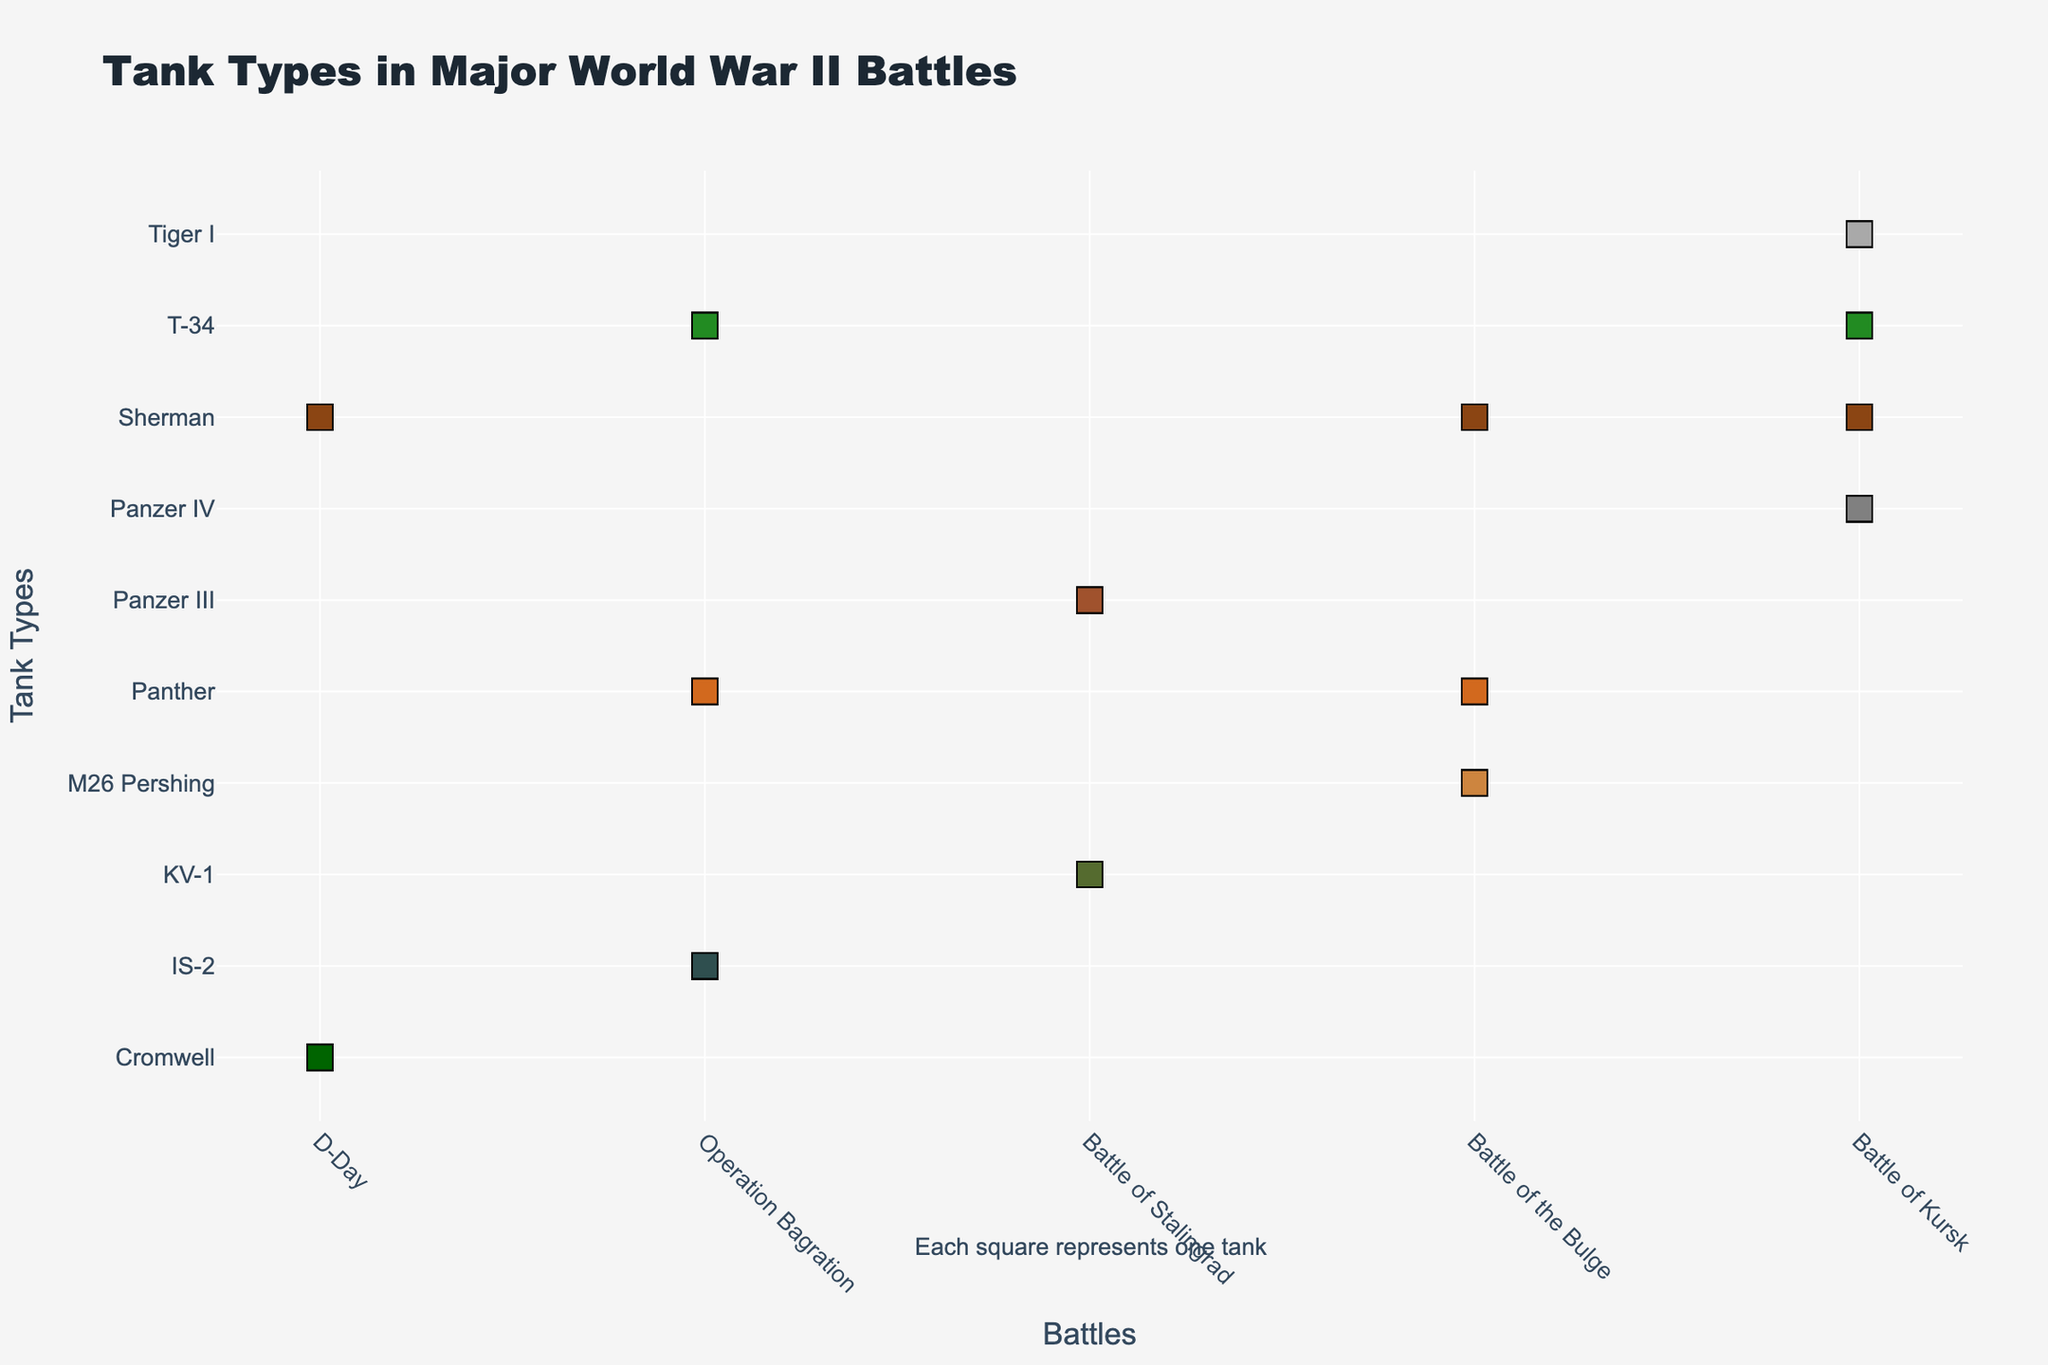Which tank type is the most frequently represented in the Battle of Kursk? Refer to the plot. The tank type with the largest number of markers (squares) in the Battle of Kursk is T-34, which has 50 markers.
Answer: T-34 Which battle features the most diverse range of tank types? Examine the number of unique tank types present in each battle. The D-Day battle features Sherman and Cromwell tanks, whereas other battles feature more tank types: The Battle of Kursk has four unique tank types (Sherman, T-34, Panzer IV, Tiger I), so it has the highest diversity.
Answer: Battle of Kursk How many Sherman tanks were used in all battles combined? Add the number of Sherman tanks from each battle: Battle of Kursk (25) + D-Day (40) + Battle of the Bulge (35). This gives 25 + 40 + 35 = 100.
Answer: 100 Which two battles feature the Panther tank, and in which battle is it more frequent? The Panther tank is present in the Battle of the Bulge and Operation Bagration. By counting the markers, we see that Operation Bagration has 25, and Battle of the Bulge has 15. Thus, it is more frequent in Operation Bagration.
Answer: Operation Bagration, Operation Bagration Compare the total count of tanks in D-Day and the Battle of Stalingrad. Which battle had more tanks? Summarize the tanks for each battle: D-Day has Sherman (40) + Cromwell (20) = 60 tanks. Battle of Stalingrad has KV-1 (30) + Panzer III (25) = 55 tanks. Comparing 60 and 55, D-Day had more tanks.
Answer: D-Day What is the average number of tanks used per battle across all battles? First, find the total number of tanks by summing all counts from the data. Then divide by the number of battles. The sum of counts is 25+50+30+10+20+40+15+35+5+30+25+60+20+25 = 390. The number of unique battles is 4 (Kursk, D-Day, Bulge, Stalingrad, Bagration). Therefore, the average is 390 / 5 = 78.
Answer: 78 Which tank type has the highest sum across all battles? Sum the counts for each tank type across all battles and compare. Sherman (25+40+35), T-34 (50+60), Panzer IV (30), Tiger I (10), Cromwell (20), Panther (15+25), M26 Pershing (5), KV-1 (30), Panzer III (25), IS-2 (20). Sherman has 25+40+35 = 100. T-34 has 50+60 = 110. T-34 has the highest sum.
Answer: T-34 